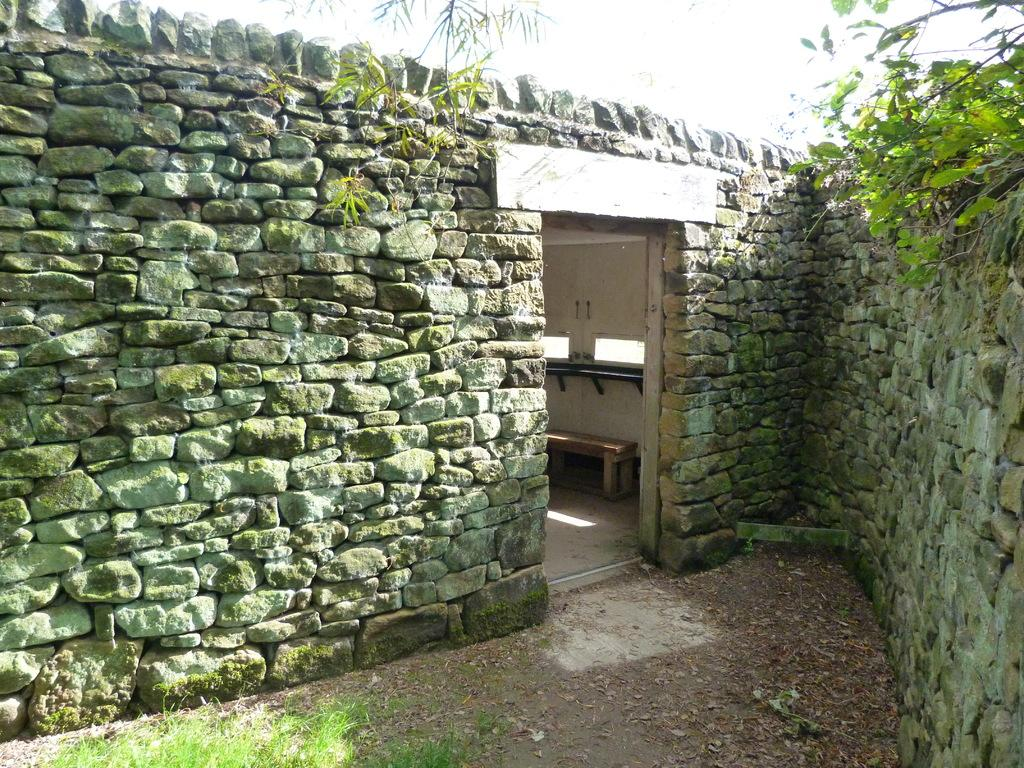What is the shape of the stone wall in the image? The stone wall in the image is in the shape of a V. What feature is present on the stone wall? There is a door on the stone wall. What can be found inside the door? Inside the door, there is a bench. Are there any plants visible on the stone wall? Yes, there are plants present on the stone wall. How does the laborer contribute to reducing pollution in the image? There is no laborer or mention of pollution in the image. The image only features a stone wall with a door, a bench, and plants. 